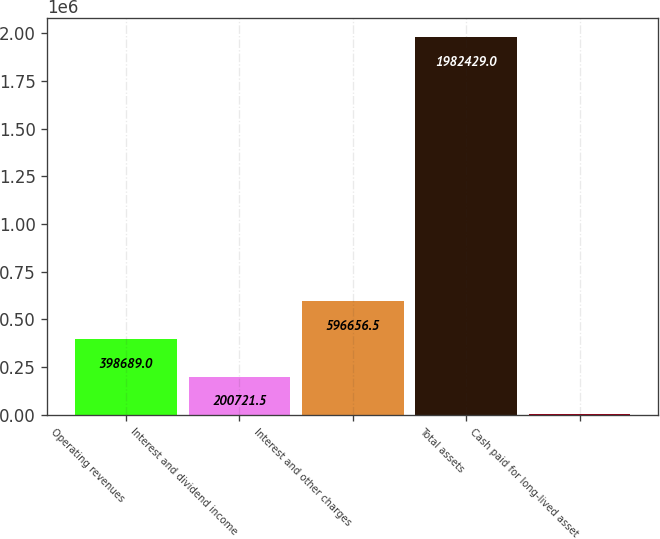Convert chart. <chart><loc_0><loc_0><loc_500><loc_500><bar_chart><fcel>Operating revenues<fcel>Interest and dividend income<fcel>Interest and other charges<fcel>Total assets<fcel>Cash paid for long-lived asset<nl><fcel>398689<fcel>200722<fcel>596656<fcel>1.98243e+06<fcel>2754<nl></chart> 